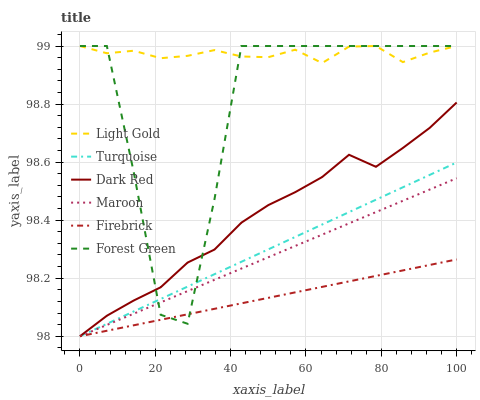Does Firebrick have the minimum area under the curve?
Answer yes or no. Yes. Does Dark Red have the minimum area under the curve?
Answer yes or no. No. Does Dark Red have the maximum area under the curve?
Answer yes or no. No. Is Maroon the smoothest?
Answer yes or no. Yes. Is Forest Green the roughest?
Answer yes or no. Yes. Is Dark Red the smoothest?
Answer yes or no. No. Is Dark Red the roughest?
Answer yes or no. No. Does Forest Green have the lowest value?
Answer yes or no. No. Does Dark Red have the highest value?
Answer yes or no. No. Is Dark Red less than Light Gold?
Answer yes or no. Yes. Is Light Gold greater than Maroon?
Answer yes or no. Yes. Does Dark Red intersect Light Gold?
Answer yes or no. No. 